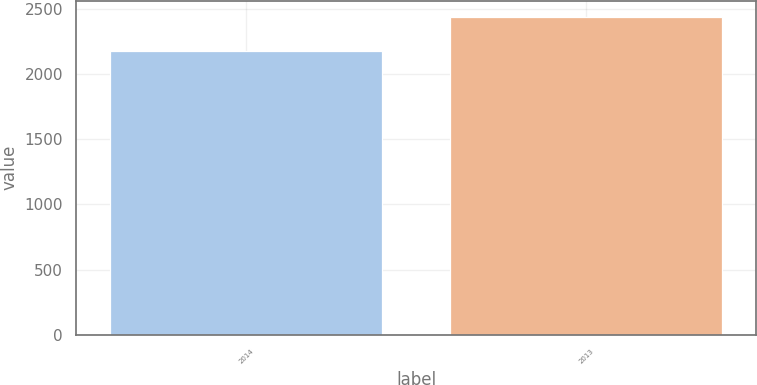Convert chart. <chart><loc_0><loc_0><loc_500><loc_500><bar_chart><fcel>2014<fcel>2013<nl><fcel>2179<fcel>2440<nl></chart> 